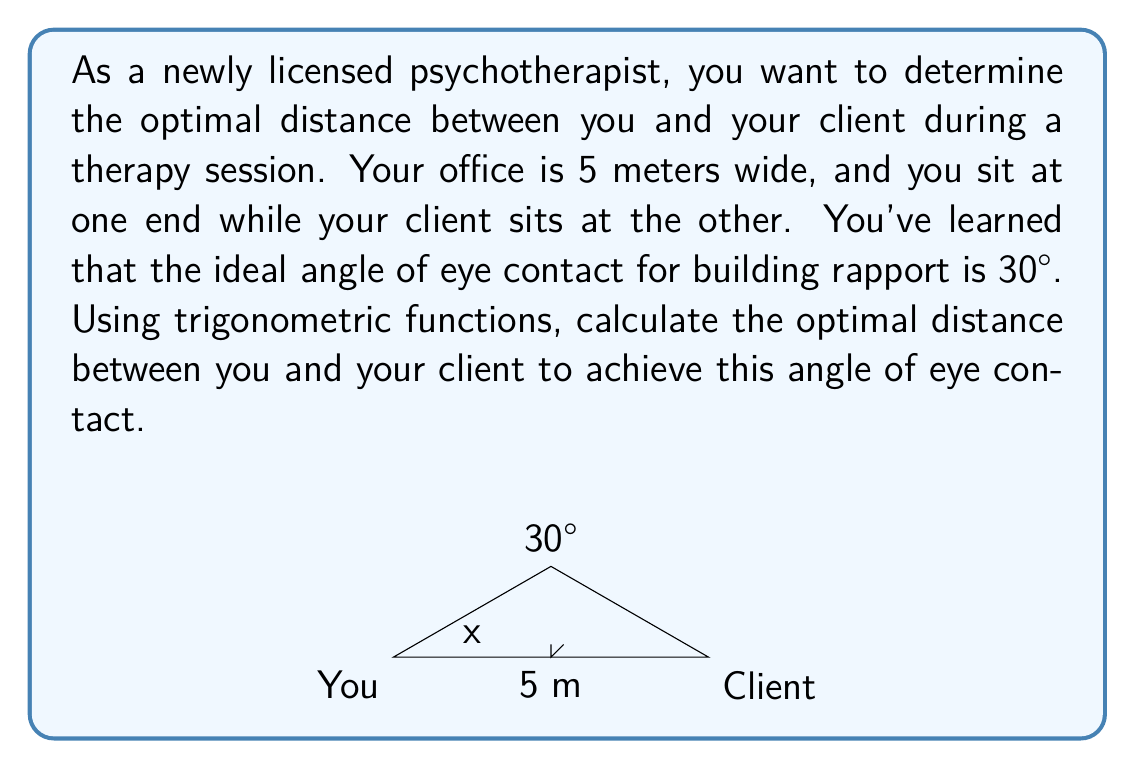What is the answer to this math problem? Let's approach this step-by-step:

1) In the diagram, we have a right triangle where:
   - The base is the width of the room (5 meters)
   - The angle of eye contact is 30°
   - We need to find the distance from either you or your client to the point where the line of sight intersects the floor

2) Let's call this distance $x$. We can use the tangent function to relate this distance to the room width:

   $$\tan(30°) = \frac{\text{opposite}}{\text{adjacent}} = \frac{2.5}{x}$$

3) We know that $\tan(30°) = \frac{1}{\sqrt{3}}$, so we can set up the equation:

   $$\frac{1}{\sqrt{3}} = \frac{2.5}{x}$$

4) Cross-multiply:

   $$x = 2.5\sqrt{3}$$

5) Calculate the value:

   $$x \approx 4.33 \text{ meters}$$

6) This is the distance from you to the midpoint of the room. The optimal distance between you and your client would be twice this:

   $$\text{Optimal distance} = 2x = 5\sqrt{3} \approx 8.66 \text{ meters}$$

However, since your office is only 5 meters wide, this optimal distance is not achievable in your current space. The closest you can get is to sit at opposite ends of the room, 5 meters apart.
Answer: The optimal distance between therapist and client for a 30° eye contact angle would be $5\sqrt{3} \approx 8.66$ meters. However, given the 5-meter width constraint of the office, the maximum achievable distance is 5 meters. 